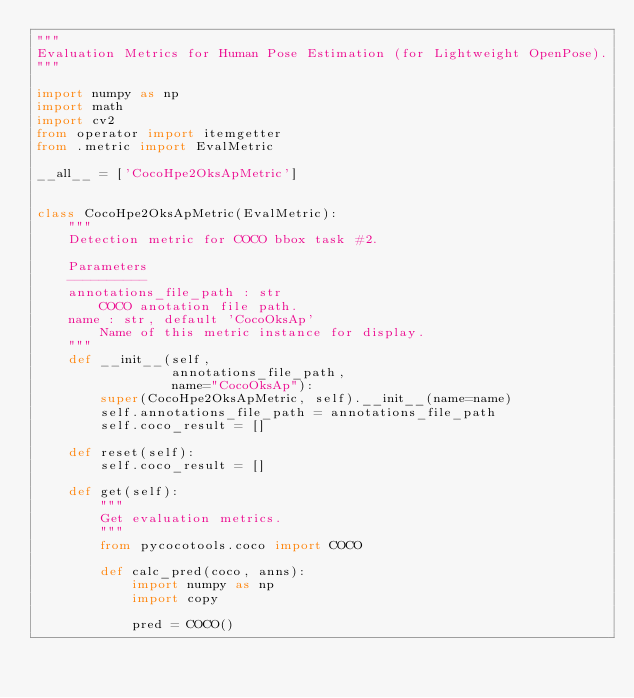<code> <loc_0><loc_0><loc_500><loc_500><_Python_>"""
Evaluation Metrics for Human Pose Estimation (for Lightweight OpenPose).
"""

import numpy as np
import math
import cv2
from operator import itemgetter
from .metric import EvalMetric

__all__ = ['CocoHpe2OksApMetric']


class CocoHpe2OksApMetric(EvalMetric):
    """
    Detection metric for COCO bbox task #2.

    Parameters
    ----------
    annotations_file_path : str
        COCO anotation file path.
    name : str, default 'CocoOksAp'
        Name of this metric instance for display.
    """
    def __init__(self,
                 annotations_file_path,
                 name="CocoOksAp"):
        super(CocoHpe2OksApMetric, self).__init__(name=name)
        self.annotations_file_path = annotations_file_path
        self.coco_result = []

    def reset(self):
        self.coco_result = []

    def get(self):
        """
        Get evaluation metrics.
        """
        from pycocotools.coco import COCO

        def calc_pred(coco, anns):
            import numpy as np
            import copy

            pred = COCO()</code> 